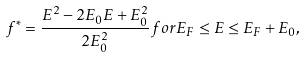Convert formula to latex. <formula><loc_0><loc_0><loc_500><loc_500>f ^ { * } = \frac { E ^ { 2 } - 2 E _ { 0 } E + E _ { 0 } ^ { 2 } } { 2 E _ { 0 } ^ { 2 } } f o r E _ { F } \leq E \leq E _ { F } + E _ { 0 } ,</formula> 